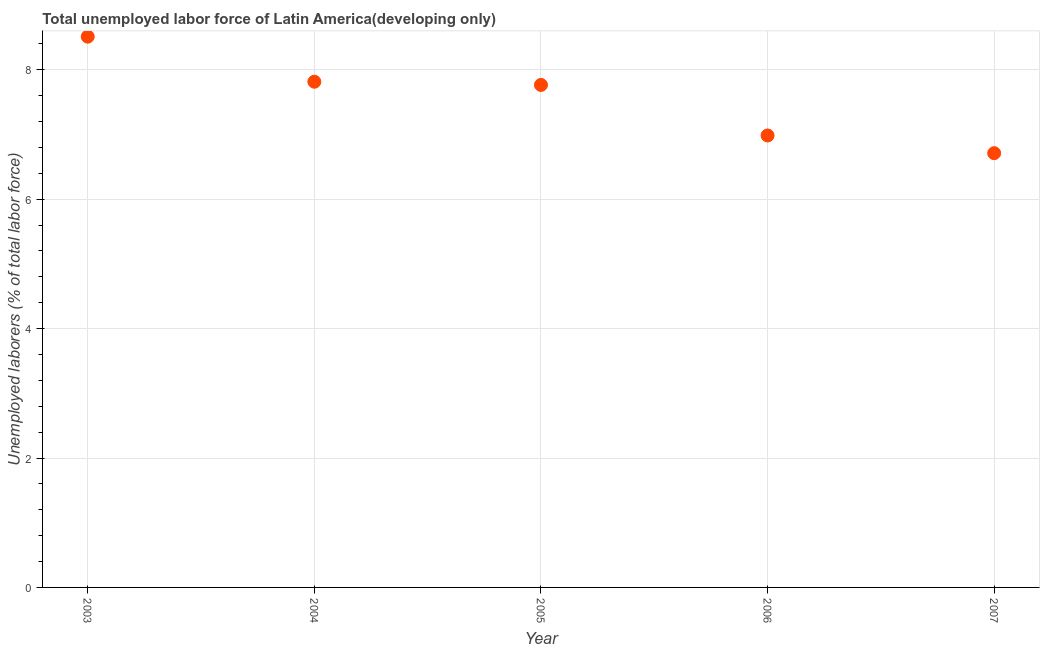What is the total unemployed labour force in 2005?
Provide a succinct answer. 7.77. Across all years, what is the maximum total unemployed labour force?
Make the answer very short. 8.51. Across all years, what is the minimum total unemployed labour force?
Ensure brevity in your answer.  6.71. In which year was the total unemployed labour force maximum?
Your answer should be compact. 2003. In which year was the total unemployed labour force minimum?
Your response must be concise. 2007. What is the sum of the total unemployed labour force?
Keep it short and to the point. 37.79. What is the difference between the total unemployed labour force in 2004 and 2005?
Ensure brevity in your answer.  0.05. What is the average total unemployed labour force per year?
Offer a terse response. 7.56. What is the median total unemployed labour force?
Provide a short and direct response. 7.77. What is the ratio of the total unemployed labour force in 2006 to that in 2007?
Make the answer very short. 1.04. Is the difference between the total unemployed labour force in 2004 and 2007 greater than the difference between any two years?
Offer a very short reply. No. What is the difference between the highest and the second highest total unemployed labour force?
Provide a succinct answer. 0.7. What is the difference between the highest and the lowest total unemployed labour force?
Ensure brevity in your answer.  1.8. Does the total unemployed labour force monotonically increase over the years?
Give a very brief answer. No. How many dotlines are there?
Keep it short and to the point. 1. What is the difference between two consecutive major ticks on the Y-axis?
Give a very brief answer. 2. What is the title of the graph?
Make the answer very short. Total unemployed labor force of Latin America(developing only). What is the label or title of the Y-axis?
Keep it short and to the point. Unemployed laborers (% of total labor force). What is the Unemployed laborers (% of total labor force) in 2003?
Keep it short and to the point. 8.51. What is the Unemployed laborers (% of total labor force) in 2004?
Give a very brief answer. 7.81. What is the Unemployed laborers (% of total labor force) in 2005?
Offer a very short reply. 7.77. What is the Unemployed laborers (% of total labor force) in 2006?
Offer a terse response. 6.98. What is the Unemployed laborers (% of total labor force) in 2007?
Make the answer very short. 6.71. What is the difference between the Unemployed laborers (% of total labor force) in 2003 and 2004?
Provide a short and direct response. 0.7. What is the difference between the Unemployed laborers (% of total labor force) in 2003 and 2005?
Offer a very short reply. 0.75. What is the difference between the Unemployed laborers (% of total labor force) in 2003 and 2006?
Provide a succinct answer. 1.53. What is the difference between the Unemployed laborers (% of total labor force) in 2003 and 2007?
Provide a succinct answer. 1.8. What is the difference between the Unemployed laborers (% of total labor force) in 2004 and 2005?
Make the answer very short. 0.05. What is the difference between the Unemployed laborers (% of total labor force) in 2004 and 2006?
Make the answer very short. 0.83. What is the difference between the Unemployed laborers (% of total labor force) in 2004 and 2007?
Provide a short and direct response. 1.1. What is the difference between the Unemployed laborers (% of total labor force) in 2005 and 2006?
Your response must be concise. 0.78. What is the difference between the Unemployed laborers (% of total labor force) in 2005 and 2007?
Make the answer very short. 1.05. What is the difference between the Unemployed laborers (% of total labor force) in 2006 and 2007?
Offer a terse response. 0.27. What is the ratio of the Unemployed laborers (% of total labor force) in 2003 to that in 2004?
Your answer should be compact. 1.09. What is the ratio of the Unemployed laborers (% of total labor force) in 2003 to that in 2005?
Your response must be concise. 1.1. What is the ratio of the Unemployed laborers (% of total labor force) in 2003 to that in 2006?
Make the answer very short. 1.22. What is the ratio of the Unemployed laborers (% of total labor force) in 2003 to that in 2007?
Give a very brief answer. 1.27. What is the ratio of the Unemployed laborers (% of total labor force) in 2004 to that in 2006?
Give a very brief answer. 1.12. What is the ratio of the Unemployed laborers (% of total labor force) in 2004 to that in 2007?
Provide a short and direct response. 1.17. What is the ratio of the Unemployed laborers (% of total labor force) in 2005 to that in 2006?
Offer a terse response. 1.11. What is the ratio of the Unemployed laborers (% of total labor force) in 2005 to that in 2007?
Give a very brief answer. 1.16. What is the ratio of the Unemployed laborers (% of total labor force) in 2006 to that in 2007?
Offer a very short reply. 1.04. 